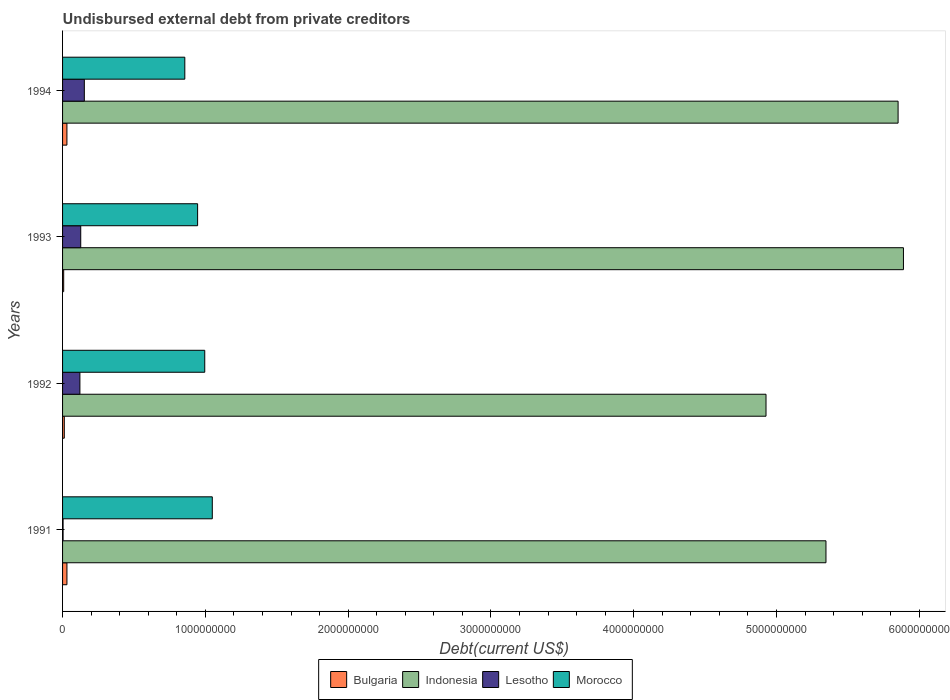How many groups of bars are there?
Give a very brief answer. 4. How many bars are there on the 4th tick from the top?
Give a very brief answer. 4. In how many cases, is the number of bars for a given year not equal to the number of legend labels?
Provide a succinct answer. 0. What is the total debt in Bulgaria in 1991?
Offer a terse response. 3.06e+07. Across all years, what is the maximum total debt in Lesotho?
Provide a succinct answer. 1.52e+08. Across all years, what is the minimum total debt in Bulgaria?
Keep it short and to the point. 7.90e+06. In which year was the total debt in Morocco minimum?
Provide a succinct answer. 1994. What is the total total debt in Bulgaria in the graph?
Give a very brief answer. 8.12e+07. What is the difference between the total debt in Lesotho in 1992 and that in 1994?
Your response must be concise. -3.09e+07. What is the difference between the total debt in Bulgaria in 1993 and the total debt in Morocco in 1991?
Offer a very short reply. -1.04e+09. What is the average total debt in Indonesia per year?
Keep it short and to the point. 5.50e+09. In the year 1994, what is the difference between the total debt in Lesotho and total debt in Morocco?
Ensure brevity in your answer.  -7.04e+08. What is the ratio of the total debt in Morocco in 1991 to that in 1992?
Offer a very short reply. 1.05. What is the difference between the highest and the second highest total debt in Bulgaria?
Offer a very short reply. 1.10e+05. What is the difference between the highest and the lowest total debt in Morocco?
Offer a terse response. 1.92e+08. Is it the case that in every year, the sum of the total debt in Lesotho and total debt in Morocco is greater than the sum of total debt in Bulgaria and total debt in Indonesia?
Your answer should be very brief. No. What does the 2nd bar from the top in 1993 represents?
Provide a succinct answer. Lesotho. What does the 4th bar from the bottom in 1992 represents?
Provide a short and direct response. Morocco. How many bars are there?
Offer a very short reply. 16. What is the difference between two consecutive major ticks on the X-axis?
Give a very brief answer. 1.00e+09. Where does the legend appear in the graph?
Keep it short and to the point. Bottom center. How are the legend labels stacked?
Make the answer very short. Horizontal. What is the title of the graph?
Keep it short and to the point. Undisbursed external debt from private creditors. What is the label or title of the X-axis?
Your response must be concise. Debt(current US$). What is the Debt(current US$) in Bulgaria in 1991?
Offer a very short reply. 3.06e+07. What is the Debt(current US$) of Indonesia in 1991?
Offer a terse response. 5.35e+09. What is the Debt(current US$) in Lesotho in 1991?
Provide a short and direct response. 3.64e+06. What is the Debt(current US$) in Morocco in 1991?
Your response must be concise. 1.05e+09. What is the Debt(current US$) in Bulgaria in 1992?
Provide a short and direct response. 1.22e+07. What is the Debt(current US$) in Indonesia in 1992?
Make the answer very short. 4.93e+09. What is the Debt(current US$) of Lesotho in 1992?
Offer a terse response. 1.21e+08. What is the Debt(current US$) in Morocco in 1992?
Provide a short and direct response. 9.96e+08. What is the Debt(current US$) in Bulgaria in 1993?
Your answer should be compact. 7.90e+06. What is the Debt(current US$) of Indonesia in 1993?
Your response must be concise. 5.89e+09. What is the Debt(current US$) of Lesotho in 1993?
Your answer should be very brief. 1.27e+08. What is the Debt(current US$) in Morocco in 1993?
Offer a terse response. 9.46e+08. What is the Debt(current US$) in Bulgaria in 1994?
Keep it short and to the point. 3.05e+07. What is the Debt(current US$) of Indonesia in 1994?
Ensure brevity in your answer.  5.85e+09. What is the Debt(current US$) in Lesotho in 1994?
Give a very brief answer. 1.52e+08. What is the Debt(current US$) in Morocco in 1994?
Provide a succinct answer. 8.56e+08. Across all years, what is the maximum Debt(current US$) of Bulgaria?
Ensure brevity in your answer.  3.06e+07. Across all years, what is the maximum Debt(current US$) in Indonesia?
Your answer should be very brief. 5.89e+09. Across all years, what is the maximum Debt(current US$) of Lesotho?
Provide a short and direct response. 1.52e+08. Across all years, what is the maximum Debt(current US$) of Morocco?
Provide a short and direct response. 1.05e+09. Across all years, what is the minimum Debt(current US$) of Bulgaria?
Your response must be concise. 7.90e+06. Across all years, what is the minimum Debt(current US$) of Indonesia?
Give a very brief answer. 4.93e+09. Across all years, what is the minimum Debt(current US$) in Lesotho?
Provide a succinct answer. 3.64e+06. Across all years, what is the minimum Debt(current US$) of Morocco?
Your answer should be compact. 8.56e+08. What is the total Debt(current US$) in Bulgaria in the graph?
Your answer should be very brief. 8.12e+07. What is the total Debt(current US$) in Indonesia in the graph?
Provide a short and direct response. 2.20e+1. What is the total Debt(current US$) in Lesotho in the graph?
Offer a terse response. 4.05e+08. What is the total Debt(current US$) in Morocco in the graph?
Give a very brief answer. 3.85e+09. What is the difference between the Debt(current US$) in Bulgaria in 1991 and that in 1992?
Give a very brief answer. 1.85e+07. What is the difference between the Debt(current US$) in Indonesia in 1991 and that in 1992?
Your response must be concise. 4.20e+08. What is the difference between the Debt(current US$) of Lesotho in 1991 and that in 1992?
Offer a very short reply. -1.18e+08. What is the difference between the Debt(current US$) of Morocco in 1991 and that in 1992?
Ensure brevity in your answer.  5.29e+07. What is the difference between the Debt(current US$) of Bulgaria in 1991 and that in 1993?
Your response must be concise. 2.27e+07. What is the difference between the Debt(current US$) of Indonesia in 1991 and that in 1993?
Give a very brief answer. -5.43e+08. What is the difference between the Debt(current US$) in Lesotho in 1991 and that in 1993?
Your answer should be very brief. -1.24e+08. What is the difference between the Debt(current US$) of Morocco in 1991 and that in 1993?
Your response must be concise. 1.03e+08. What is the difference between the Debt(current US$) in Indonesia in 1991 and that in 1994?
Provide a short and direct response. -5.05e+08. What is the difference between the Debt(current US$) in Lesotho in 1991 and that in 1994?
Your answer should be very brief. -1.49e+08. What is the difference between the Debt(current US$) in Morocco in 1991 and that in 1994?
Keep it short and to the point. 1.92e+08. What is the difference between the Debt(current US$) of Bulgaria in 1992 and that in 1993?
Your answer should be compact. 4.25e+06. What is the difference between the Debt(current US$) of Indonesia in 1992 and that in 1993?
Your response must be concise. -9.63e+08. What is the difference between the Debt(current US$) of Lesotho in 1992 and that in 1993?
Your answer should be very brief. -5.79e+06. What is the difference between the Debt(current US$) of Morocco in 1992 and that in 1993?
Keep it short and to the point. 5.00e+07. What is the difference between the Debt(current US$) in Bulgaria in 1992 and that in 1994?
Your answer should be very brief. -1.84e+07. What is the difference between the Debt(current US$) of Indonesia in 1992 and that in 1994?
Your response must be concise. -9.25e+08. What is the difference between the Debt(current US$) in Lesotho in 1992 and that in 1994?
Provide a succinct answer. -3.09e+07. What is the difference between the Debt(current US$) in Morocco in 1992 and that in 1994?
Provide a succinct answer. 1.40e+08. What is the difference between the Debt(current US$) in Bulgaria in 1993 and that in 1994?
Your answer should be very brief. -2.26e+07. What is the difference between the Debt(current US$) in Indonesia in 1993 and that in 1994?
Give a very brief answer. 3.75e+07. What is the difference between the Debt(current US$) of Lesotho in 1993 and that in 1994?
Your answer should be compact. -2.51e+07. What is the difference between the Debt(current US$) in Morocco in 1993 and that in 1994?
Your answer should be very brief. 8.96e+07. What is the difference between the Debt(current US$) in Bulgaria in 1991 and the Debt(current US$) in Indonesia in 1992?
Ensure brevity in your answer.  -4.90e+09. What is the difference between the Debt(current US$) in Bulgaria in 1991 and the Debt(current US$) in Lesotho in 1992?
Ensure brevity in your answer.  -9.08e+07. What is the difference between the Debt(current US$) of Bulgaria in 1991 and the Debt(current US$) of Morocco in 1992?
Ensure brevity in your answer.  -9.65e+08. What is the difference between the Debt(current US$) in Indonesia in 1991 and the Debt(current US$) in Lesotho in 1992?
Provide a short and direct response. 5.22e+09. What is the difference between the Debt(current US$) in Indonesia in 1991 and the Debt(current US$) in Morocco in 1992?
Give a very brief answer. 4.35e+09. What is the difference between the Debt(current US$) of Lesotho in 1991 and the Debt(current US$) of Morocco in 1992?
Your answer should be very brief. -9.92e+08. What is the difference between the Debt(current US$) of Bulgaria in 1991 and the Debt(current US$) of Indonesia in 1993?
Give a very brief answer. -5.86e+09. What is the difference between the Debt(current US$) of Bulgaria in 1991 and the Debt(current US$) of Lesotho in 1993?
Keep it short and to the point. -9.66e+07. What is the difference between the Debt(current US$) of Bulgaria in 1991 and the Debt(current US$) of Morocco in 1993?
Your response must be concise. -9.15e+08. What is the difference between the Debt(current US$) of Indonesia in 1991 and the Debt(current US$) of Lesotho in 1993?
Keep it short and to the point. 5.22e+09. What is the difference between the Debt(current US$) in Indonesia in 1991 and the Debt(current US$) in Morocco in 1993?
Your answer should be very brief. 4.40e+09. What is the difference between the Debt(current US$) of Lesotho in 1991 and the Debt(current US$) of Morocco in 1993?
Give a very brief answer. -9.42e+08. What is the difference between the Debt(current US$) of Bulgaria in 1991 and the Debt(current US$) of Indonesia in 1994?
Your answer should be compact. -5.82e+09. What is the difference between the Debt(current US$) of Bulgaria in 1991 and the Debt(current US$) of Lesotho in 1994?
Keep it short and to the point. -1.22e+08. What is the difference between the Debt(current US$) in Bulgaria in 1991 and the Debt(current US$) in Morocco in 1994?
Ensure brevity in your answer.  -8.25e+08. What is the difference between the Debt(current US$) of Indonesia in 1991 and the Debt(current US$) of Lesotho in 1994?
Provide a short and direct response. 5.19e+09. What is the difference between the Debt(current US$) in Indonesia in 1991 and the Debt(current US$) in Morocco in 1994?
Give a very brief answer. 4.49e+09. What is the difference between the Debt(current US$) of Lesotho in 1991 and the Debt(current US$) of Morocco in 1994?
Give a very brief answer. -8.52e+08. What is the difference between the Debt(current US$) in Bulgaria in 1992 and the Debt(current US$) in Indonesia in 1993?
Provide a succinct answer. -5.88e+09. What is the difference between the Debt(current US$) of Bulgaria in 1992 and the Debt(current US$) of Lesotho in 1993?
Your answer should be compact. -1.15e+08. What is the difference between the Debt(current US$) of Bulgaria in 1992 and the Debt(current US$) of Morocco in 1993?
Offer a very short reply. -9.34e+08. What is the difference between the Debt(current US$) of Indonesia in 1992 and the Debt(current US$) of Lesotho in 1993?
Provide a succinct answer. 4.80e+09. What is the difference between the Debt(current US$) in Indonesia in 1992 and the Debt(current US$) in Morocco in 1993?
Offer a very short reply. 3.98e+09. What is the difference between the Debt(current US$) of Lesotho in 1992 and the Debt(current US$) of Morocco in 1993?
Ensure brevity in your answer.  -8.24e+08. What is the difference between the Debt(current US$) of Bulgaria in 1992 and the Debt(current US$) of Indonesia in 1994?
Provide a succinct answer. -5.84e+09. What is the difference between the Debt(current US$) of Bulgaria in 1992 and the Debt(current US$) of Lesotho in 1994?
Give a very brief answer. -1.40e+08. What is the difference between the Debt(current US$) of Bulgaria in 1992 and the Debt(current US$) of Morocco in 1994?
Keep it short and to the point. -8.44e+08. What is the difference between the Debt(current US$) in Indonesia in 1992 and the Debt(current US$) in Lesotho in 1994?
Give a very brief answer. 4.77e+09. What is the difference between the Debt(current US$) of Indonesia in 1992 and the Debt(current US$) of Morocco in 1994?
Offer a terse response. 4.07e+09. What is the difference between the Debt(current US$) of Lesotho in 1992 and the Debt(current US$) of Morocco in 1994?
Offer a very short reply. -7.35e+08. What is the difference between the Debt(current US$) in Bulgaria in 1993 and the Debt(current US$) in Indonesia in 1994?
Make the answer very short. -5.84e+09. What is the difference between the Debt(current US$) in Bulgaria in 1993 and the Debt(current US$) in Lesotho in 1994?
Your response must be concise. -1.44e+08. What is the difference between the Debt(current US$) in Bulgaria in 1993 and the Debt(current US$) in Morocco in 1994?
Keep it short and to the point. -8.48e+08. What is the difference between the Debt(current US$) in Indonesia in 1993 and the Debt(current US$) in Lesotho in 1994?
Provide a succinct answer. 5.74e+09. What is the difference between the Debt(current US$) in Indonesia in 1993 and the Debt(current US$) in Morocco in 1994?
Offer a very short reply. 5.03e+09. What is the difference between the Debt(current US$) in Lesotho in 1993 and the Debt(current US$) in Morocco in 1994?
Ensure brevity in your answer.  -7.29e+08. What is the average Debt(current US$) in Bulgaria per year?
Your response must be concise. 2.03e+07. What is the average Debt(current US$) in Indonesia per year?
Provide a short and direct response. 5.50e+09. What is the average Debt(current US$) of Lesotho per year?
Your response must be concise. 1.01e+08. What is the average Debt(current US$) of Morocco per year?
Your response must be concise. 9.62e+08. In the year 1991, what is the difference between the Debt(current US$) in Bulgaria and Debt(current US$) in Indonesia?
Offer a very short reply. -5.32e+09. In the year 1991, what is the difference between the Debt(current US$) of Bulgaria and Debt(current US$) of Lesotho?
Give a very brief answer. 2.70e+07. In the year 1991, what is the difference between the Debt(current US$) of Bulgaria and Debt(current US$) of Morocco?
Keep it short and to the point. -1.02e+09. In the year 1991, what is the difference between the Debt(current US$) of Indonesia and Debt(current US$) of Lesotho?
Keep it short and to the point. 5.34e+09. In the year 1991, what is the difference between the Debt(current US$) of Indonesia and Debt(current US$) of Morocco?
Your answer should be compact. 4.30e+09. In the year 1991, what is the difference between the Debt(current US$) in Lesotho and Debt(current US$) in Morocco?
Offer a very short reply. -1.04e+09. In the year 1992, what is the difference between the Debt(current US$) of Bulgaria and Debt(current US$) of Indonesia?
Make the answer very short. -4.91e+09. In the year 1992, what is the difference between the Debt(current US$) in Bulgaria and Debt(current US$) in Lesotho?
Ensure brevity in your answer.  -1.09e+08. In the year 1992, what is the difference between the Debt(current US$) of Bulgaria and Debt(current US$) of Morocco?
Offer a terse response. -9.84e+08. In the year 1992, what is the difference between the Debt(current US$) of Indonesia and Debt(current US$) of Lesotho?
Your response must be concise. 4.80e+09. In the year 1992, what is the difference between the Debt(current US$) of Indonesia and Debt(current US$) of Morocco?
Provide a short and direct response. 3.93e+09. In the year 1992, what is the difference between the Debt(current US$) of Lesotho and Debt(current US$) of Morocco?
Make the answer very short. -8.74e+08. In the year 1993, what is the difference between the Debt(current US$) of Bulgaria and Debt(current US$) of Indonesia?
Your response must be concise. -5.88e+09. In the year 1993, what is the difference between the Debt(current US$) of Bulgaria and Debt(current US$) of Lesotho?
Provide a succinct answer. -1.19e+08. In the year 1993, what is the difference between the Debt(current US$) of Bulgaria and Debt(current US$) of Morocco?
Give a very brief answer. -9.38e+08. In the year 1993, what is the difference between the Debt(current US$) of Indonesia and Debt(current US$) of Lesotho?
Provide a succinct answer. 5.76e+09. In the year 1993, what is the difference between the Debt(current US$) of Indonesia and Debt(current US$) of Morocco?
Offer a very short reply. 4.94e+09. In the year 1993, what is the difference between the Debt(current US$) in Lesotho and Debt(current US$) in Morocco?
Give a very brief answer. -8.18e+08. In the year 1994, what is the difference between the Debt(current US$) of Bulgaria and Debt(current US$) of Indonesia?
Your answer should be compact. -5.82e+09. In the year 1994, what is the difference between the Debt(current US$) in Bulgaria and Debt(current US$) in Lesotho?
Your answer should be compact. -1.22e+08. In the year 1994, what is the difference between the Debt(current US$) in Bulgaria and Debt(current US$) in Morocco?
Offer a terse response. -8.26e+08. In the year 1994, what is the difference between the Debt(current US$) of Indonesia and Debt(current US$) of Lesotho?
Give a very brief answer. 5.70e+09. In the year 1994, what is the difference between the Debt(current US$) of Indonesia and Debt(current US$) of Morocco?
Provide a short and direct response. 5.00e+09. In the year 1994, what is the difference between the Debt(current US$) in Lesotho and Debt(current US$) in Morocco?
Provide a short and direct response. -7.04e+08. What is the ratio of the Debt(current US$) of Bulgaria in 1991 to that in 1992?
Offer a terse response. 2.52. What is the ratio of the Debt(current US$) in Indonesia in 1991 to that in 1992?
Make the answer very short. 1.09. What is the ratio of the Debt(current US$) in Lesotho in 1991 to that in 1992?
Provide a short and direct response. 0.03. What is the ratio of the Debt(current US$) of Morocco in 1991 to that in 1992?
Ensure brevity in your answer.  1.05. What is the ratio of the Debt(current US$) in Bulgaria in 1991 to that in 1993?
Ensure brevity in your answer.  3.87. What is the ratio of the Debt(current US$) in Indonesia in 1991 to that in 1993?
Offer a very short reply. 0.91. What is the ratio of the Debt(current US$) in Lesotho in 1991 to that in 1993?
Provide a succinct answer. 0.03. What is the ratio of the Debt(current US$) of Morocco in 1991 to that in 1993?
Your answer should be compact. 1.11. What is the ratio of the Debt(current US$) in Bulgaria in 1991 to that in 1994?
Your response must be concise. 1. What is the ratio of the Debt(current US$) of Indonesia in 1991 to that in 1994?
Ensure brevity in your answer.  0.91. What is the ratio of the Debt(current US$) of Lesotho in 1991 to that in 1994?
Provide a succinct answer. 0.02. What is the ratio of the Debt(current US$) of Morocco in 1991 to that in 1994?
Provide a succinct answer. 1.22. What is the ratio of the Debt(current US$) of Bulgaria in 1992 to that in 1993?
Offer a terse response. 1.54. What is the ratio of the Debt(current US$) in Indonesia in 1992 to that in 1993?
Keep it short and to the point. 0.84. What is the ratio of the Debt(current US$) in Lesotho in 1992 to that in 1993?
Provide a short and direct response. 0.95. What is the ratio of the Debt(current US$) of Morocco in 1992 to that in 1993?
Keep it short and to the point. 1.05. What is the ratio of the Debt(current US$) in Bulgaria in 1992 to that in 1994?
Make the answer very short. 0.4. What is the ratio of the Debt(current US$) of Indonesia in 1992 to that in 1994?
Keep it short and to the point. 0.84. What is the ratio of the Debt(current US$) of Lesotho in 1992 to that in 1994?
Your response must be concise. 0.8. What is the ratio of the Debt(current US$) in Morocco in 1992 to that in 1994?
Offer a very short reply. 1.16. What is the ratio of the Debt(current US$) in Bulgaria in 1993 to that in 1994?
Your answer should be very brief. 0.26. What is the ratio of the Debt(current US$) in Indonesia in 1993 to that in 1994?
Offer a very short reply. 1.01. What is the ratio of the Debt(current US$) of Lesotho in 1993 to that in 1994?
Give a very brief answer. 0.84. What is the ratio of the Debt(current US$) of Morocco in 1993 to that in 1994?
Your response must be concise. 1.1. What is the difference between the highest and the second highest Debt(current US$) of Indonesia?
Offer a terse response. 3.75e+07. What is the difference between the highest and the second highest Debt(current US$) in Lesotho?
Provide a succinct answer. 2.51e+07. What is the difference between the highest and the second highest Debt(current US$) of Morocco?
Offer a terse response. 5.29e+07. What is the difference between the highest and the lowest Debt(current US$) of Bulgaria?
Provide a short and direct response. 2.27e+07. What is the difference between the highest and the lowest Debt(current US$) in Indonesia?
Give a very brief answer. 9.63e+08. What is the difference between the highest and the lowest Debt(current US$) of Lesotho?
Make the answer very short. 1.49e+08. What is the difference between the highest and the lowest Debt(current US$) of Morocco?
Your response must be concise. 1.92e+08. 